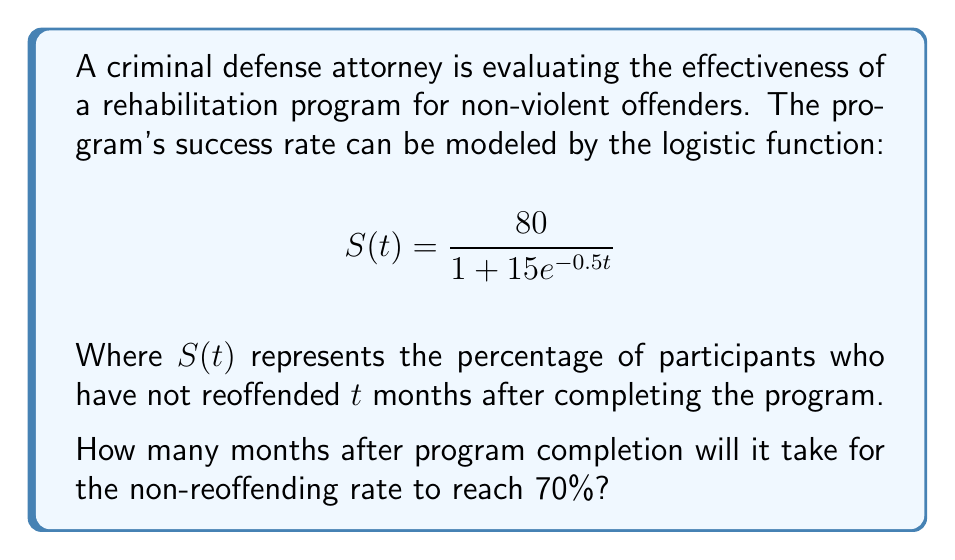Can you answer this question? To solve this problem, we need to follow these steps:

1) We want to find $t$ when $S(t) = 70$. So, we set up the equation:

   $$70 = \frac{80}{1 + 15e^{-0.5t}}$$

2) Multiply both sides by $(1 + 15e^{-0.5t})$:

   $$70(1 + 15e^{-0.5t}) = 80$$

3) Distribute on the left side:

   $$70 + 1050e^{-0.5t} = 80$$

4) Subtract 70 from both sides:

   $$1050e^{-0.5t} = 10$$

5) Divide both sides by 1050:

   $$e^{-0.5t} = \frac{1}{105}$$

6) Take the natural log of both sides:

   $$-0.5t = \ln(\frac{1}{105})$$

7) Divide both sides by -0.5:

   $$t = -\frac{2\ln(\frac{1}{105})}{1} = 2\ln(105)$$

8) Calculate the value (rounded to two decimal places):

   $$t \approx 9.30$$

Therefore, it will take approximately 9.30 months for the non-reoffending rate to reach 70%.
Answer: $9.30$ months 